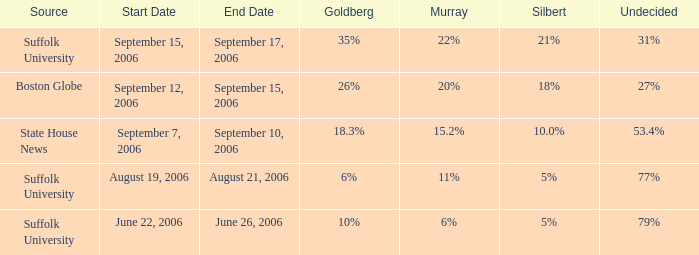What is the undecided percentage of the poll where Goldberg had 6%? 77%. 